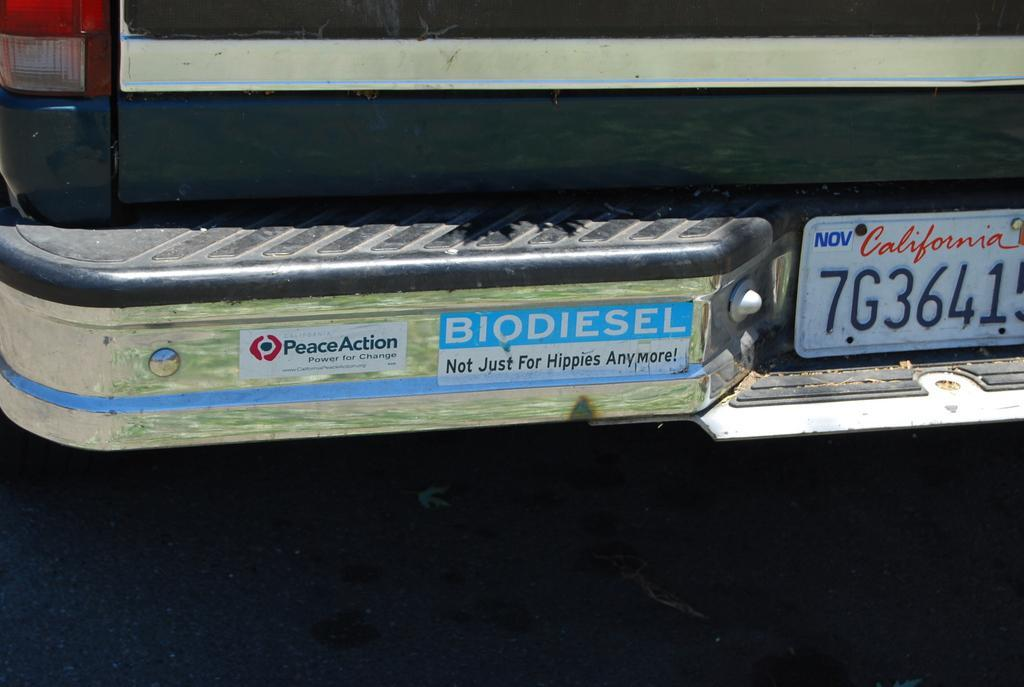Provide a one-sentence caption for the provided image. A car with a bumper sticker saying Biodiesel not just for hippies anymore. 